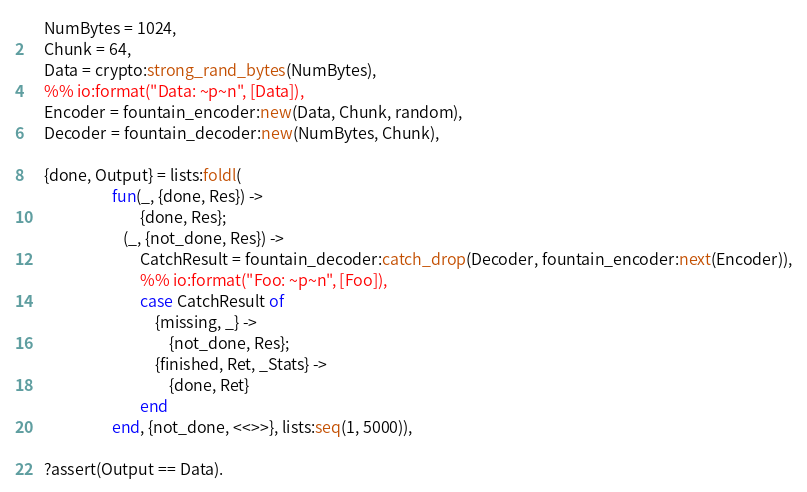Convert code to text. <code><loc_0><loc_0><loc_500><loc_500><_Erlang_>    NumBytes = 1024,
    Chunk = 64,
    Data = crypto:strong_rand_bytes(NumBytes),
    %% io:format("Data: ~p~n", [Data]),
    Encoder = fountain_encoder:new(Data, Chunk, random),
    Decoder = fountain_decoder:new(NumBytes, Chunk),

    {done, Output} = lists:foldl(
                       fun(_, {done, Res}) ->
                               {done, Res};
                          (_, {not_done, Res}) ->
                               CatchResult = fountain_decoder:catch_drop(Decoder, fountain_encoder:next(Encoder)),
                               %% io:format("Foo: ~p~n", [Foo]),
                               case CatchResult of
                                   {missing, _} ->
                                       {not_done, Res};
                                   {finished, Ret, _Stats} ->
                                       {done, Ret}
                               end
                       end, {not_done, <<>>}, lists:seq(1, 5000)),

    ?assert(Output == Data).
</code> 